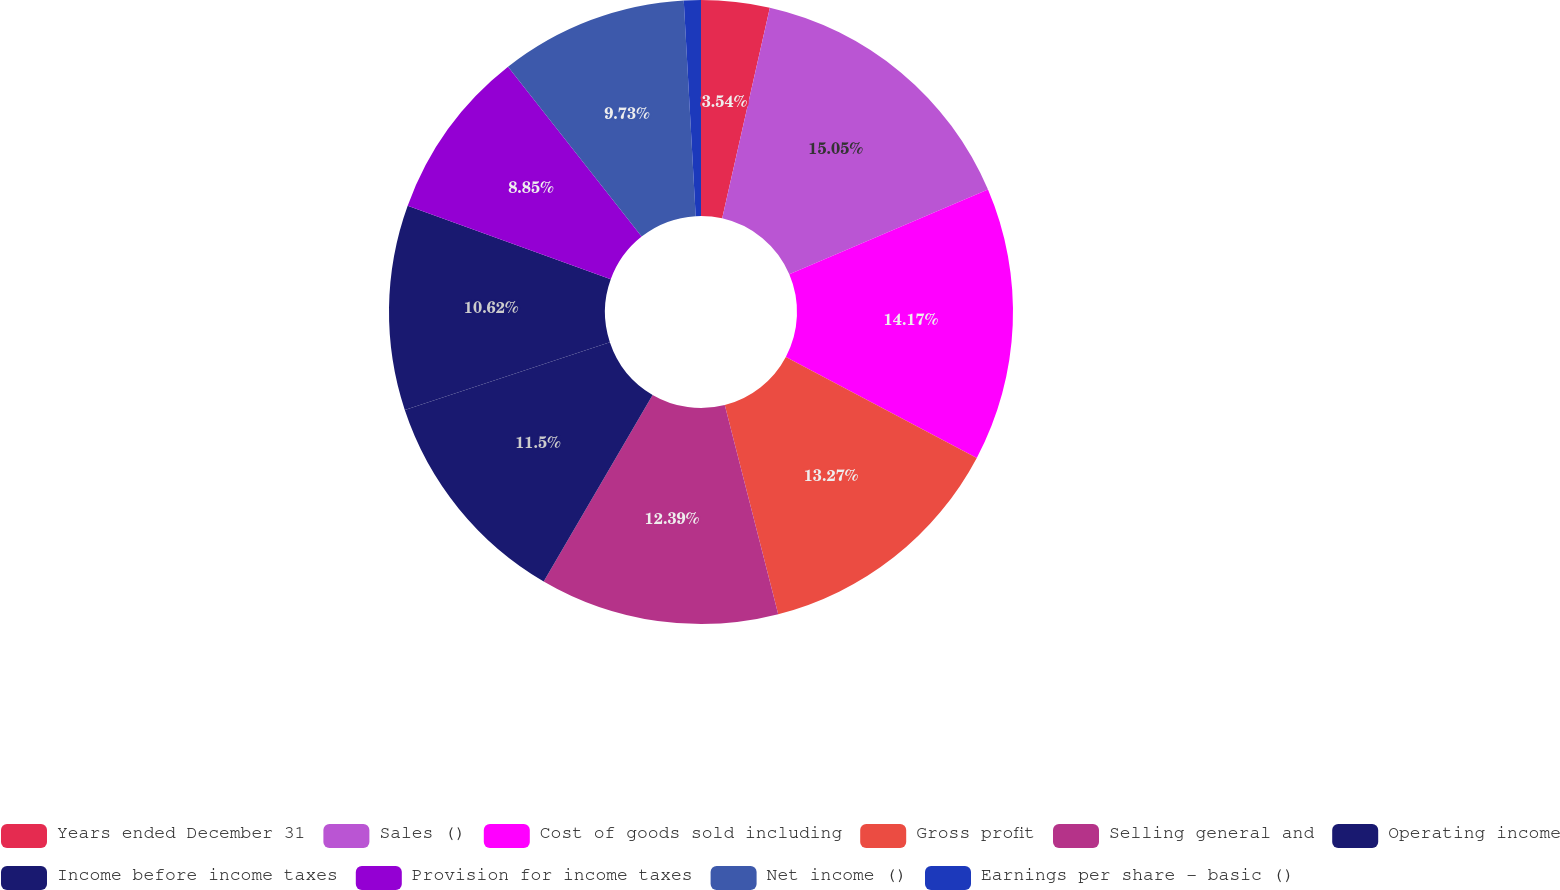<chart> <loc_0><loc_0><loc_500><loc_500><pie_chart><fcel>Years ended December 31<fcel>Sales ()<fcel>Cost of goods sold including<fcel>Gross profit<fcel>Selling general and<fcel>Operating income<fcel>Income before income taxes<fcel>Provision for income taxes<fcel>Net income ()<fcel>Earnings per share - basic ()<nl><fcel>3.54%<fcel>15.04%<fcel>14.16%<fcel>13.27%<fcel>12.39%<fcel>11.5%<fcel>10.62%<fcel>8.85%<fcel>9.73%<fcel>0.88%<nl></chart> 